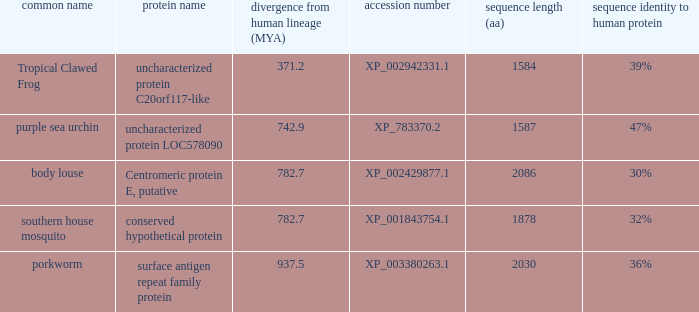What accession number corresponds to the protein diverging 937.5 from the human lineage? XP_003380263.1. 